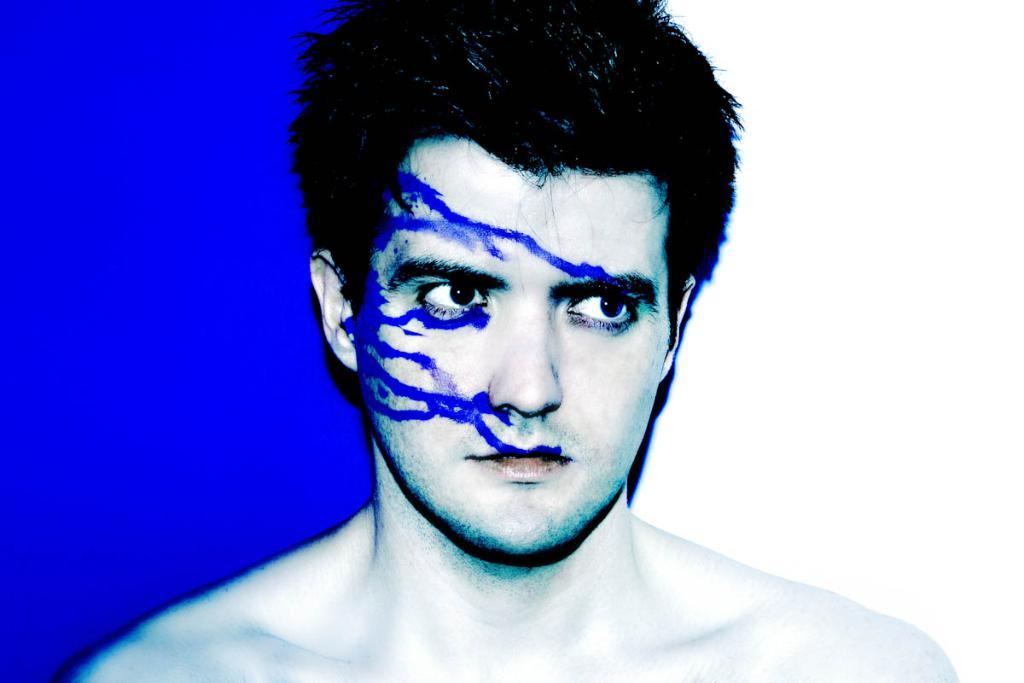What is the main subject of the image? There is a person in the image. What can be observed on the person's face? The person has blue color paint on their face. What colors are present in the background of the image? The background of the image is blue and white. How many pizzas are being served on the roll in the image? There are no pizzas or rolls present in the image. What type of seat is visible in the image? There is no seat visible in the image. 